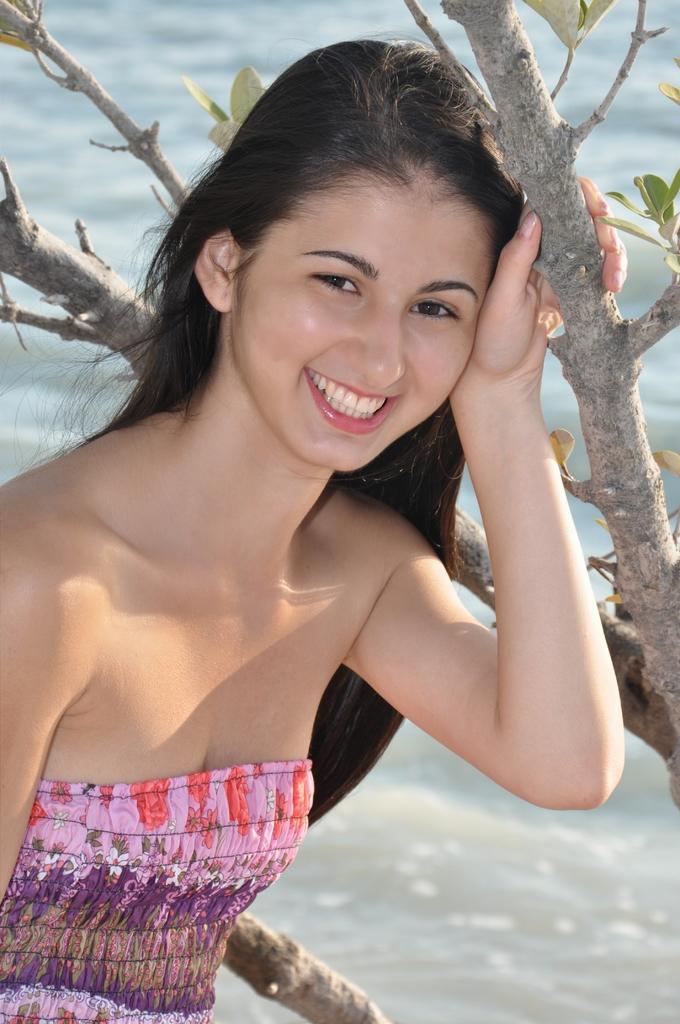Describe this image in one or two sentences. In this picture we can see a woman, she is smiling, beside to her we can see a tree and water. 